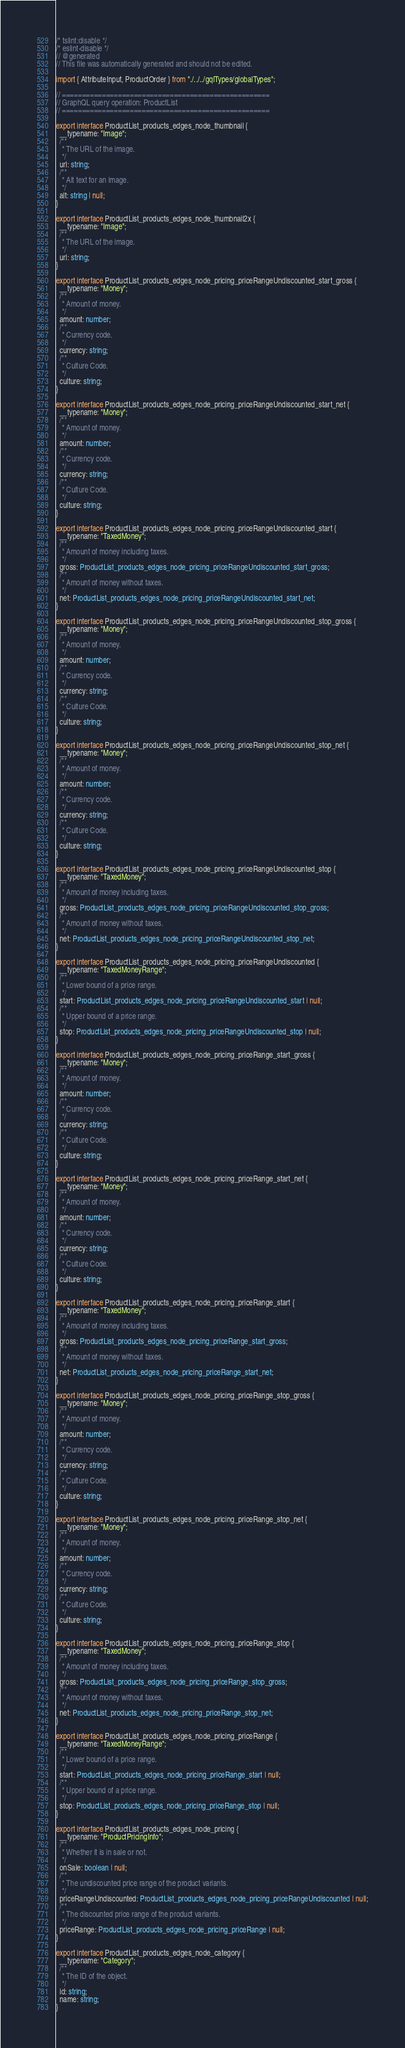<code> <loc_0><loc_0><loc_500><loc_500><_TypeScript_>/* tslint:disable */
/* eslint-disable */
// @generated
// This file was automatically generated and should not be edited.

import { AttributeInput, ProductOrder } from "./../../gqlTypes/globalTypes";

// ====================================================
// GraphQL query operation: ProductList
// ====================================================

export interface ProductList_products_edges_node_thumbnail {
  __typename: "Image";
  /**
   * The URL of the image.
   */
  url: string;
  /**
   * Alt text for an image.
   */
  alt: string | null;
}

export interface ProductList_products_edges_node_thumbnail2x {
  __typename: "Image";
  /**
   * The URL of the image.
   */
  url: string;
}

export interface ProductList_products_edges_node_pricing_priceRangeUndiscounted_start_gross {
  __typename: "Money";
  /**
   * Amount of money.
   */
  amount: number;
  /**
   * Currency code.
   */
  currency: string;
  /**
   * Culture Code.
   */
  culture: string;
}

export interface ProductList_products_edges_node_pricing_priceRangeUndiscounted_start_net {
  __typename: "Money";
  /**
   * Amount of money.
   */
  amount: number;
  /**
   * Currency code.
   */
  currency: string;
  /**
   * Culture Code.
   */
  culture: string;
}

export interface ProductList_products_edges_node_pricing_priceRangeUndiscounted_start {
  __typename: "TaxedMoney";
  /**
   * Amount of money including taxes.
   */
  gross: ProductList_products_edges_node_pricing_priceRangeUndiscounted_start_gross;
  /**
   * Amount of money without taxes.
   */
  net: ProductList_products_edges_node_pricing_priceRangeUndiscounted_start_net;
}

export interface ProductList_products_edges_node_pricing_priceRangeUndiscounted_stop_gross {
  __typename: "Money";
  /**
   * Amount of money.
   */
  amount: number;
  /**
   * Currency code.
   */
  currency: string;
  /**
   * Culture Code.
   */
  culture: string;
}

export interface ProductList_products_edges_node_pricing_priceRangeUndiscounted_stop_net {
  __typename: "Money";
  /**
   * Amount of money.
   */
  amount: number;
  /**
   * Currency code.
   */
  currency: string;
  /**
   * Culture Code.
   */
  culture: string;
}

export interface ProductList_products_edges_node_pricing_priceRangeUndiscounted_stop {
  __typename: "TaxedMoney";
  /**
   * Amount of money including taxes.
   */
  gross: ProductList_products_edges_node_pricing_priceRangeUndiscounted_stop_gross;
  /**
   * Amount of money without taxes.
   */
  net: ProductList_products_edges_node_pricing_priceRangeUndiscounted_stop_net;
}

export interface ProductList_products_edges_node_pricing_priceRangeUndiscounted {
  __typename: "TaxedMoneyRange";
  /**
   * Lower bound of a price range.
   */
  start: ProductList_products_edges_node_pricing_priceRangeUndiscounted_start | null;
  /**
   * Upper bound of a price range.
   */
  stop: ProductList_products_edges_node_pricing_priceRangeUndiscounted_stop | null;
}

export interface ProductList_products_edges_node_pricing_priceRange_start_gross {
  __typename: "Money";
  /**
   * Amount of money.
   */
  amount: number;
  /**
   * Currency code.
   */
  currency: string;
  /**
   * Culture Code.
   */
  culture: string;
}

export interface ProductList_products_edges_node_pricing_priceRange_start_net {
  __typename: "Money";
  /**
   * Amount of money.
   */
  amount: number;
  /**
   * Currency code.
   */
  currency: string;
  /**
   * Culture Code.
   */
  culture: string;
}

export interface ProductList_products_edges_node_pricing_priceRange_start {
  __typename: "TaxedMoney";
  /**
   * Amount of money including taxes.
   */
  gross: ProductList_products_edges_node_pricing_priceRange_start_gross;
  /**
   * Amount of money without taxes.
   */
  net: ProductList_products_edges_node_pricing_priceRange_start_net;
}

export interface ProductList_products_edges_node_pricing_priceRange_stop_gross {
  __typename: "Money";
  /**
   * Amount of money.
   */
  amount: number;
  /**
   * Currency code.
   */
  currency: string;
  /**
   * Culture Code.
   */
  culture: string;
}

export interface ProductList_products_edges_node_pricing_priceRange_stop_net {
  __typename: "Money";
  /**
   * Amount of money.
   */
  amount: number;
  /**
   * Currency code.
   */
  currency: string;
  /**
   * Culture Code.
   */
  culture: string;
}

export interface ProductList_products_edges_node_pricing_priceRange_stop {
  __typename: "TaxedMoney";
  /**
   * Amount of money including taxes.
   */
  gross: ProductList_products_edges_node_pricing_priceRange_stop_gross;
  /**
   * Amount of money without taxes.
   */
  net: ProductList_products_edges_node_pricing_priceRange_stop_net;
}

export interface ProductList_products_edges_node_pricing_priceRange {
  __typename: "TaxedMoneyRange";
  /**
   * Lower bound of a price range.
   */
  start: ProductList_products_edges_node_pricing_priceRange_start | null;
  /**
   * Upper bound of a price range.
   */
  stop: ProductList_products_edges_node_pricing_priceRange_stop | null;
}

export interface ProductList_products_edges_node_pricing {
  __typename: "ProductPricingInfo";
  /**
   * Whether it is in sale or not.
   */
  onSale: boolean | null;
  /**
   * The undiscounted price range of the product variants.
   */
  priceRangeUndiscounted: ProductList_products_edges_node_pricing_priceRangeUndiscounted | null;
  /**
   * The discounted price range of the product variants.
   */
  priceRange: ProductList_products_edges_node_pricing_priceRange | null;
}

export interface ProductList_products_edges_node_category {
  __typename: "Category";
  /**
   * The ID of the object.
   */
  id: string;
  name: string;
}
</code> 